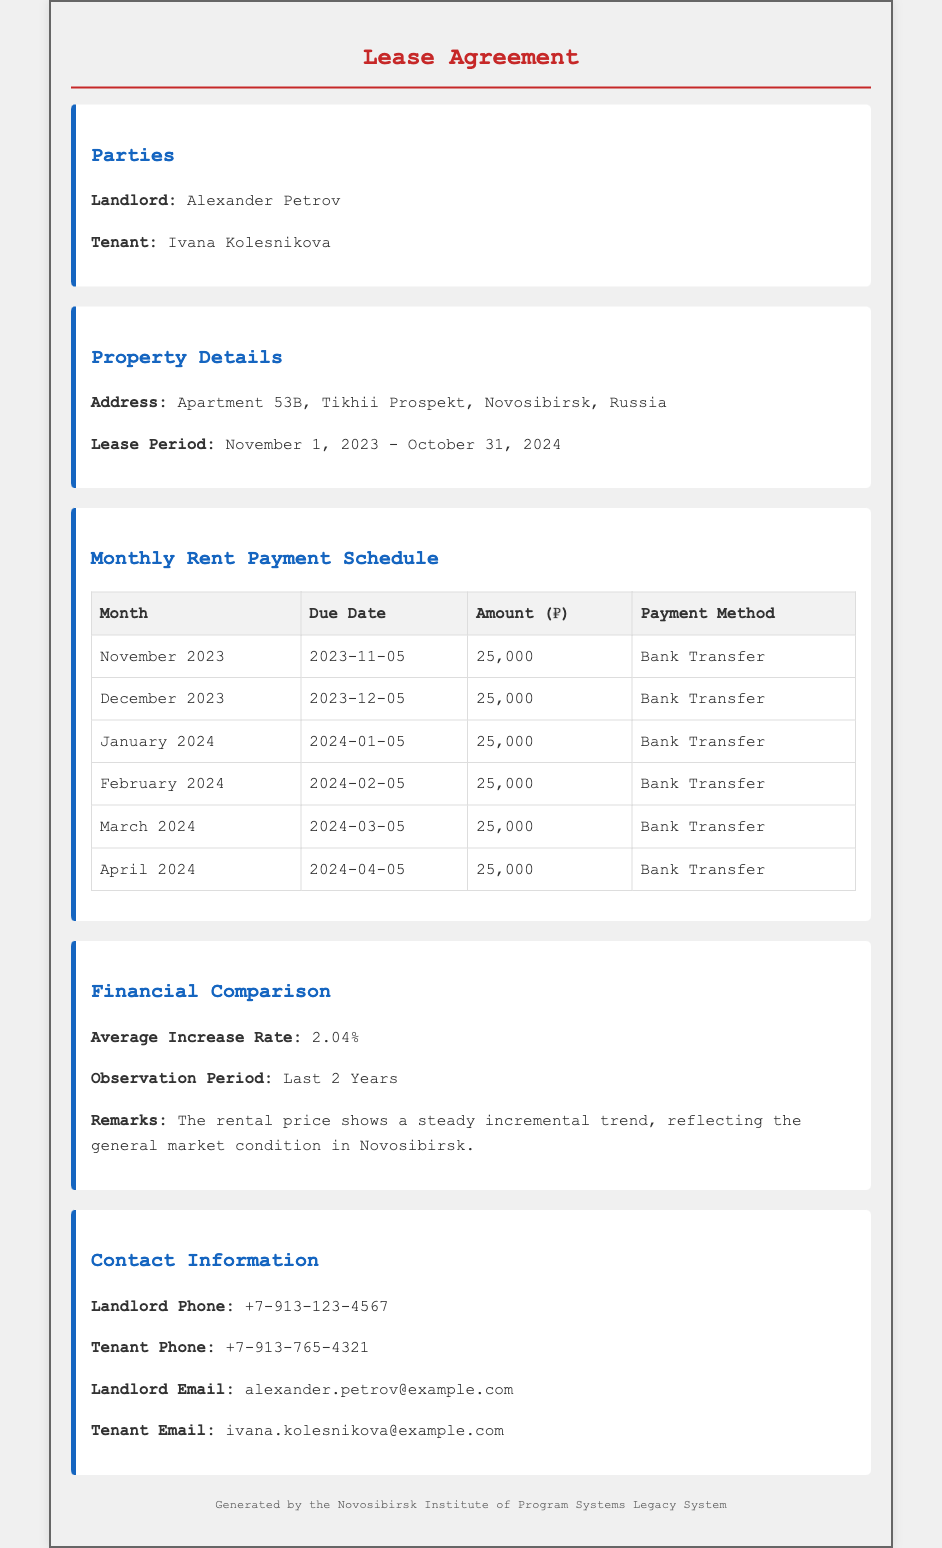What is the landlord's name? The document states the landlord's name is Alexander Petrov.
Answer: Alexander Petrov What is the monthly rent amount? The amount listed for the rent in the payment schedule is 25,000 rubles.
Answer: 25,000 When is the rent due for January 2024? The due date for January 2024 is specified as January 5, 2024.
Answer: 2024-01-05 What is the average increase rate over the observation period? The document indicates the average increase rate as 2.04%.
Answer: 2.04% What method of payment is specified in the agreement? The payment method mentioned for the rent is Bank Transfer.
Answer: Bank Transfer How long is the lease period? The lease period spans from November 1, 2023, to October 31, 2024.
Answer: November 1, 2023 - October 31, 2024 How many months of rent are detailed in the payment schedule? The payment schedule covers six months of rent, from November 2023 until April 2024.
Answer: Six months What was the observation period for the financial comparison? The document specifies that the observation period was the last two years.
Answer: Last 2 Years 